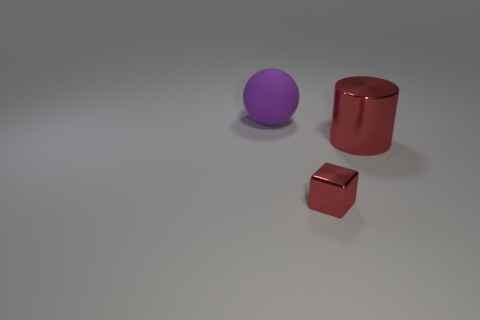Are the shadows cast by the objects indicative of a single light source? Yes, the shadows of the objects on the ground align in a manner which suggests they are being cast by a single light source situated above and to the right of the scene. 